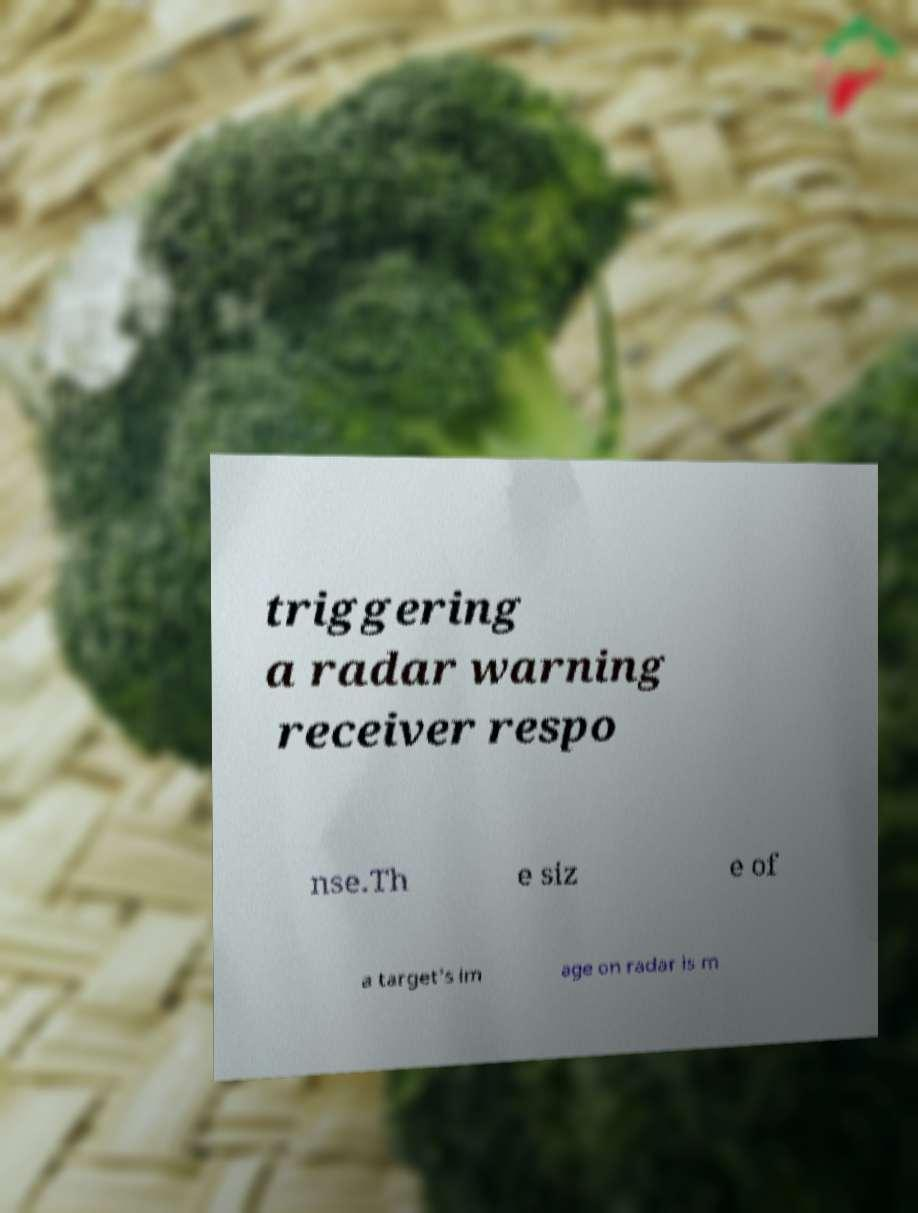Can you accurately transcribe the text from the provided image for me? triggering a radar warning receiver respo nse.Th e siz e of a target's im age on radar is m 